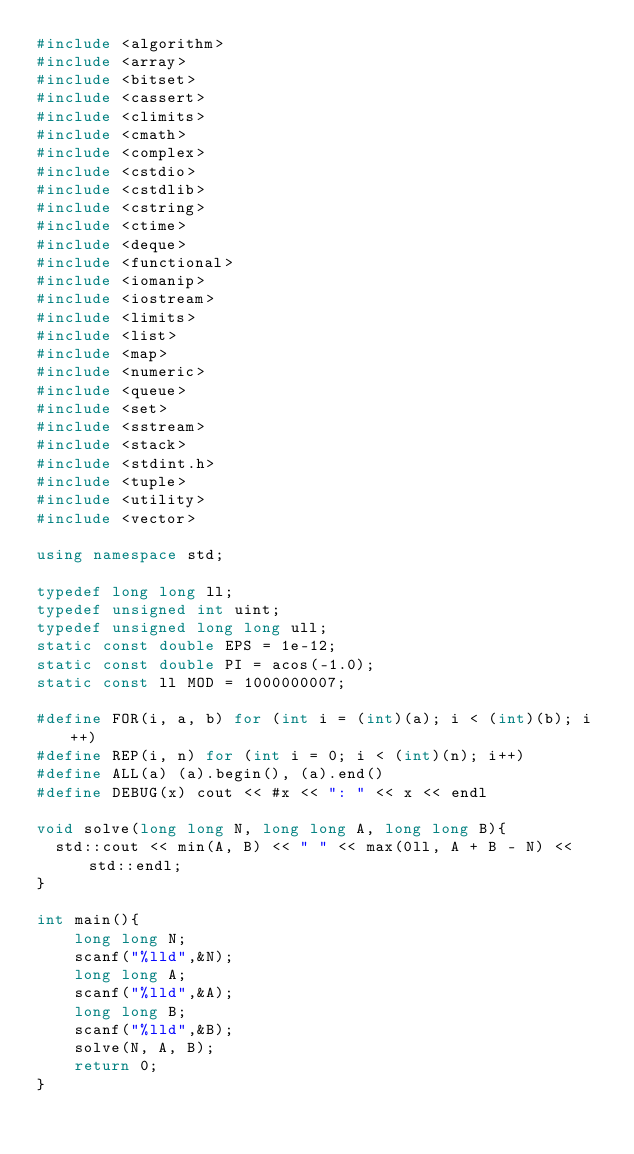Convert code to text. <code><loc_0><loc_0><loc_500><loc_500><_C++_>#include <algorithm>
#include <array>
#include <bitset>
#include <cassert>
#include <climits>
#include <cmath>
#include <complex>
#include <cstdio>
#include <cstdlib>
#include <cstring>
#include <ctime>
#include <deque>
#include <functional>
#include <iomanip>
#include <iostream>
#include <limits>
#include <list>
#include <map>
#include <numeric>
#include <queue>
#include <set>
#include <sstream>
#include <stack>
#include <stdint.h>
#include <tuple>
#include <utility>
#include <vector>
 
using namespace std;
 
typedef long long ll;
typedef unsigned int uint;
typedef unsigned long long ull;
static const double EPS = 1e-12;
static const double PI = acos(-1.0);
static const ll MOD = 1000000007;
 
#define FOR(i, a, b) for (int i = (int)(a); i < (int)(b); i++)
#define REP(i, n) for (int i = 0; i < (int)(n); i++)
#define ALL(a) (a).begin(), (a).end()
#define DEBUG(x) cout << #x << ": " << x << endl

void solve(long long N, long long A, long long B){
  std::cout << min(A, B) << " " << max(0ll, A + B - N) << std::endl;
}

int main(){
    long long N;
    scanf("%lld",&N);
    long long A;
    scanf("%lld",&A);
    long long B;
    scanf("%lld",&B);
    solve(N, A, B);
    return 0;
}
</code> 